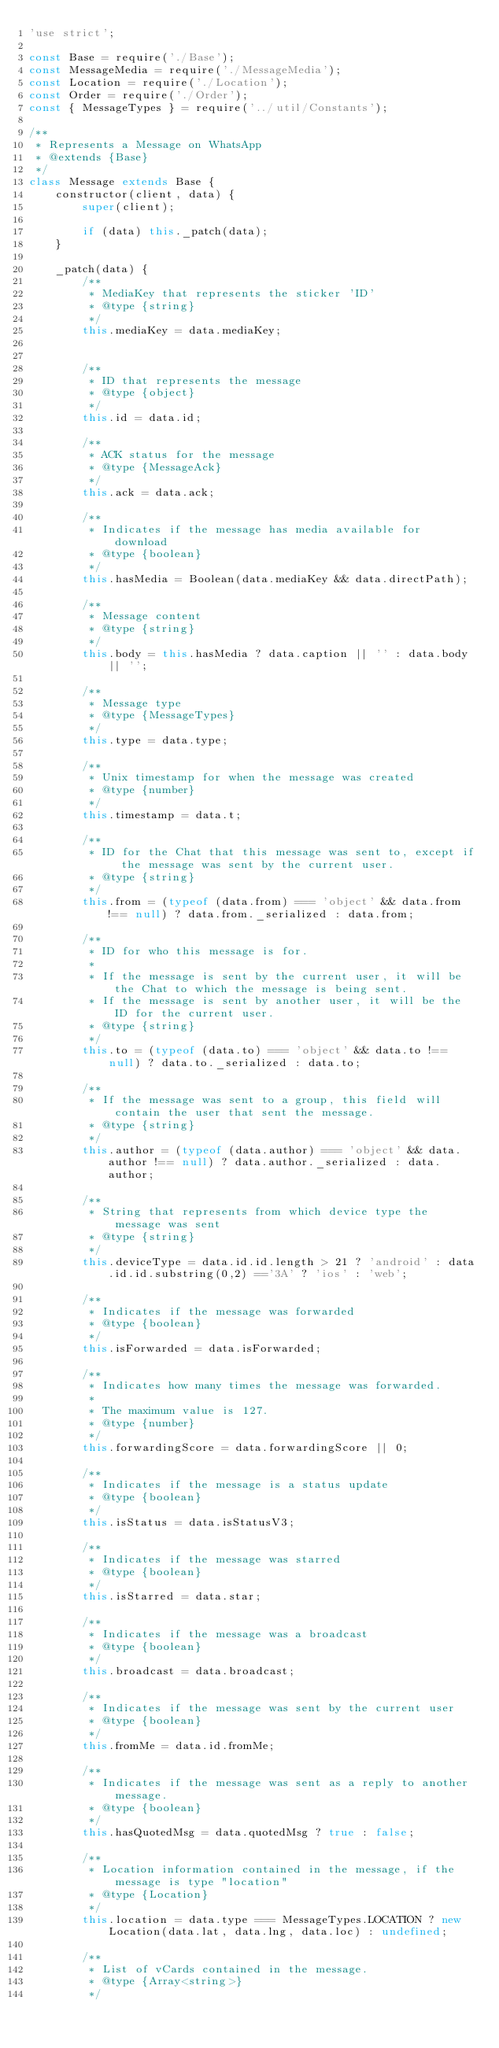Convert code to text. <code><loc_0><loc_0><loc_500><loc_500><_JavaScript_>'use strict';

const Base = require('./Base');
const MessageMedia = require('./MessageMedia');
const Location = require('./Location');
const Order = require('./Order');
const { MessageTypes } = require('../util/Constants');

/**
 * Represents a Message on WhatsApp
 * @extends {Base}
 */
class Message extends Base {
    constructor(client, data) {
        super(client);

        if (data) this._patch(data);
    }

    _patch(data) {
        /**
         * MediaKey that represents the sticker 'ID'
         * @type {string}
         */
        this.mediaKey = data.mediaKey;


        /**
         * ID that represents the message
         * @type {object}
         */
        this.id = data.id;

        /**
         * ACK status for the message
         * @type {MessageAck}
         */
        this.ack = data.ack;

        /**
         * Indicates if the message has media available for download
         * @type {boolean}
         */
        this.hasMedia = Boolean(data.mediaKey && data.directPath);

        /**
         * Message content
         * @type {string}
         */
        this.body = this.hasMedia ? data.caption || '' : data.body || '';

        /** 
         * Message type
         * @type {MessageTypes}
         */
        this.type = data.type;

        /**
         * Unix timestamp for when the message was created
         * @type {number}
         */
        this.timestamp = data.t;

        /**
         * ID for the Chat that this message was sent to, except if the message was sent by the current user.
         * @type {string}
         */
        this.from = (typeof (data.from) === 'object' && data.from !== null) ? data.from._serialized : data.from;

        /**
         * ID for who this message is for.
         * 
         * If the message is sent by the current user, it will be the Chat to which the message is being sent.
         * If the message is sent by another user, it will be the ID for the current user. 
         * @type {string}
         */
        this.to = (typeof (data.to) === 'object' && data.to !== null) ? data.to._serialized : data.to;

        /**
         * If the message was sent to a group, this field will contain the user that sent the message.
         * @type {string}
         */
        this.author = (typeof (data.author) === 'object' && data.author !== null) ? data.author._serialized : data.author;

        /**
         * String that represents from which device type the message was sent
         * @type {string}
         */
        this.deviceType = data.id.id.length > 21 ? 'android' : data.id.id.substring(0,2) =='3A' ? 'ios' : 'web';
        
        /**
         * Indicates if the message was forwarded
         * @type {boolean}
         */
        this.isForwarded = data.isForwarded;

        /**
         * Indicates how many times the message was forwarded.
         *
         * The maximum value is 127.
         * @type {number}
         */
        this.forwardingScore = data.forwardingScore || 0;

        /**
         * Indicates if the message is a status update
         * @type {boolean}
         */
        this.isStatus = data.isStatusV3;

        /**
         * Indicates if the message was starred
         * @type {boolean}
         */
        this.isStarred = data.star;
        
        /**
         * Indicates if the message was a broadcast
         * @type {boolean}
         */
        this.broadcast = data.broadcast;

        /** 
         * Indicates if the message was sent by the current user
         * @type {boolean}
         */
        this.fromMe = data.id.fromMe;

        /**
         * Indicates if the message was sent as a reply to another message.
         * @type {boolean}
         */
        this.hasQuotedMsg = data.quotedMsg ? true : false;

        /**
         * Location information contained in the message, if the message is type "location"
         * @type {Location}
         */
        this.location = data.type === MessageTypes.LOCATION ? new Location(data.lat, data.lng, data.loc) : undefined;

        /**
         * List of vCards contained in the message.
         * @type {Array<string>}
         */</code> 